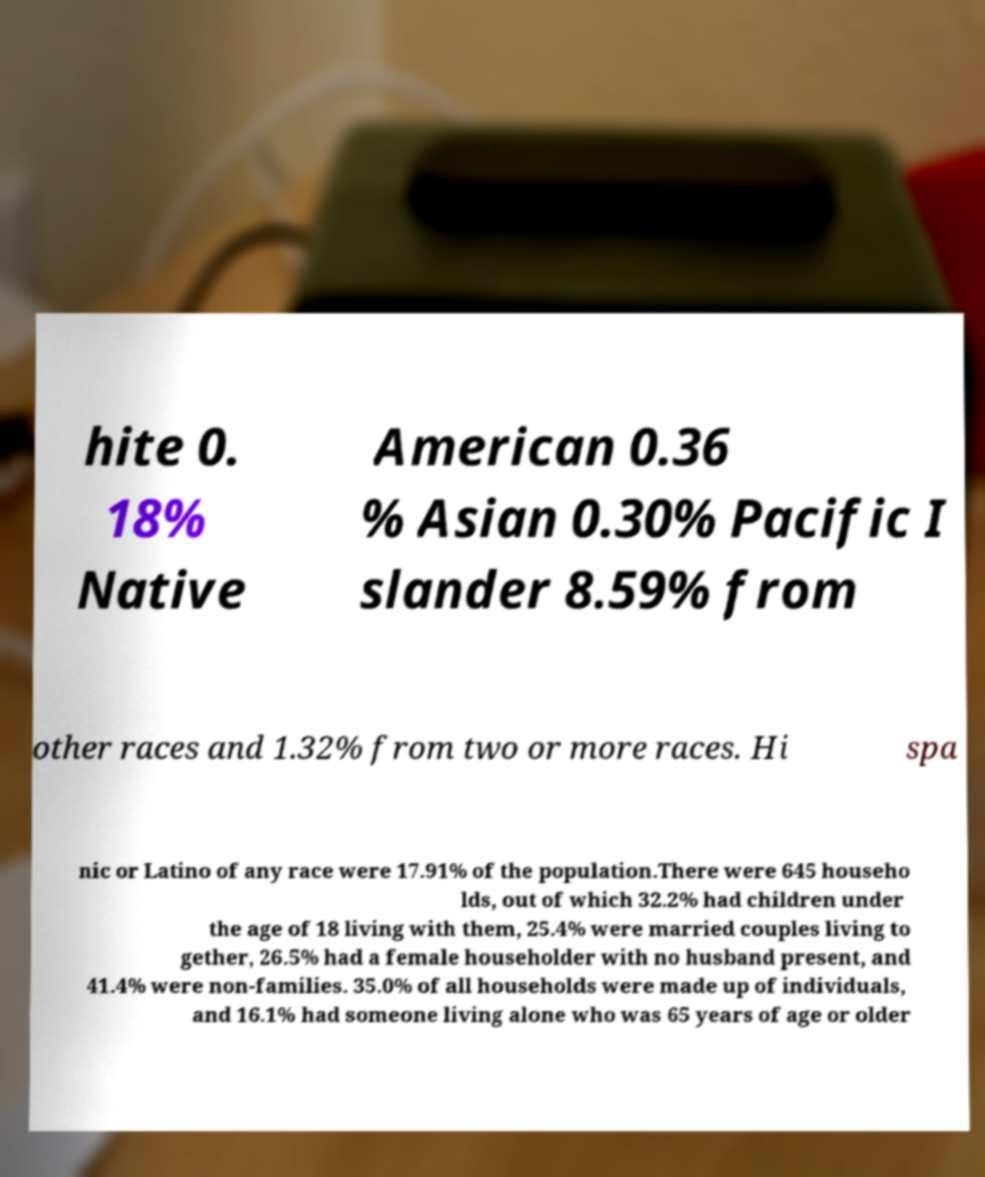I need the written content from this picture converted into text. Can you do that? hite 0. 18% Native American 0.36 % Asian 0.30% Pacific I slander 8.59% from other races and 1.32% from two or more races. Hi spa nic or Latino of any race were 17.91% of the population.There were 645 househo lds, out of which 32.2% had children under the age of 18 living with them, 25.4% were married couples living to gether, 26.5% had a female householder with no husband present, and 41.4% were non-families. 35.0% of all households were made up of individuals, and 16.1% had someone living alone who was 65 years of age or older 